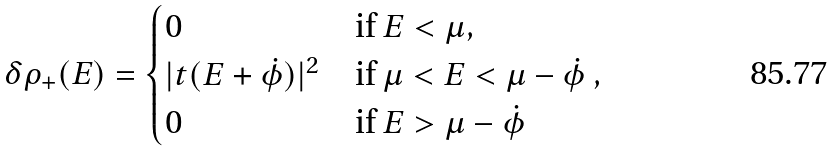Convert formula to latex. <formula><loc_0><loc_0><loc_500><loc_500>\delta \rho _ { + } ( E ) = \begin{cases} 0 & \text {if $E < \mu$} , \\ | t ( E + \dot { \phi } ) | ^ { 2 } & \text {if $\mu < E < \mu-\dot{\phi} $ } , \\ 0 & \text {if $E > \mu-\dot{\phi}$} \end{cases}</formula> 